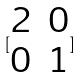Convert formula to latex. <formula><loc_0><loc_0><loc_500><loc_500>[ \begin{matrix} 2 & 0 \\ 0 & 1 \end{matrix} ]</formula> 